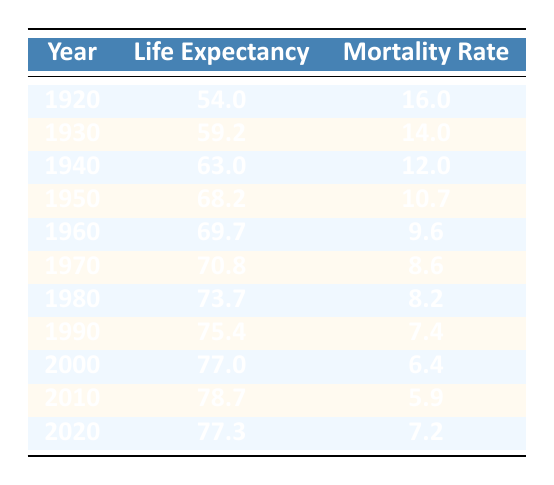What was the life expectancy in the United States in 1960? The life expectancy for the year 1960 is directly listed in the table as 69.7 years.
Answer: 69.7 What is the mortality rate for the year 2000 in the United States? The mortality rate for the year 2000 is provided in the table, and it is listed as 6.4.
Answer: 6.4 What is the difference in life expectancy between 1920 and 2010? The life expectancy in 1920 was 54.0 years and in 2010 it was 78.7 years. The difference is 78.7 - 54.0 = 24.7 years.
Answer: 24.7 Is the mortality rate in 1980 lower than that in 1950? The mortality rate in 1980 is 8.2 while in 1950 it is 10.7. Since 8.2 is less than 10.7, the statement is true.
Answer: Yes What was the average life expectancy in the United States from 1920 to 2020? To find the average, sum the life expectancies: 54.0 + 59.2 + 63.0 + 68.2 + 69.7 + 70.8 + 73.7 + 75.4 + 77.0 + 78.7 + 77.3 =  689.0. There are 11 years, so the average is 689.0 / 11 = 62.64 years.
Answer: 62.64 Did the life expectancy in 2020 increase compared to 2010? In 2010, the life expectancy was 78.7 years, but in 2020 it decreased to 77.3 years. Thus, 2020 did not see an increase compared to 2010.
Answer: No What was the trend in mortality rates from 1920 to 2010? The data shows a consistent decrease in mortality rates from 16.0 in 1920 to 5.9 in 2010, indicating a downward trend.
Answer: Downward trend Calculate the percentage decrease in mortality rate from 1930 to 2020. The mortality rate in 1930 was 14.0, and in 2020 it was 7.2. The decrease is 14.0 - 7.2 = 6.8. The percentage decrease is (6.8 / 14.0) * 100 = 48.57%.
Answer: 48.57% 